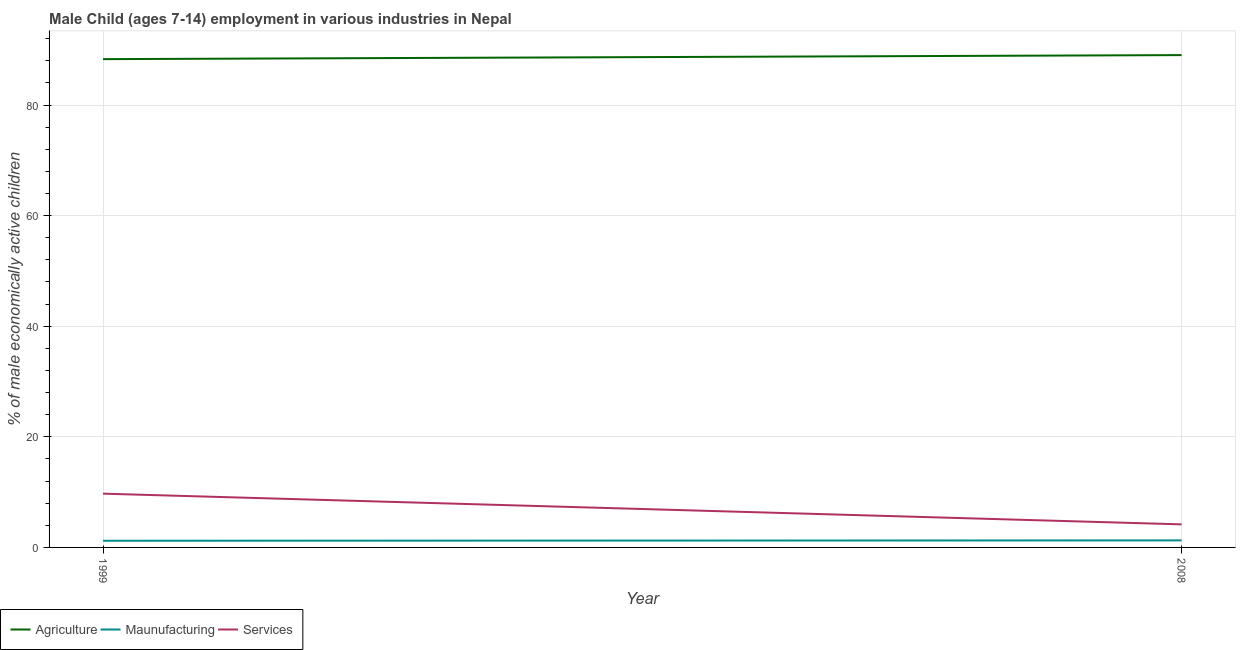Does the line corresponding to percentage of economically active children in manufacturing intersect with the line corresponding to percentage of economically active children in services?
Provide a short and direct response. No. Is the number of lines equal to the number of legend labels?
Your answer should be very brief. Yes. What is the percentage of economically active children in services in 1999?
Ensure brevity in your answer.  9.72. Across all years, what is the maximum percentage of economically active children in agriculture?
Your response must be concise. 89.03. Across all years, what is the minimum percentage of economically active children in manufacturing?
Provide a short and direct response. 1.2. In which year was the percentage of economically active children in services minimum?
Provide a short and direct response. 2008. What is the total percentage of economically active children in services in the graph?
Offer a very short reply. 13.89. What is the difference between the percentage of economically active children in agriculture in 1999 and that in 2008?
Your answer should be very brief. -0.73. What is the difference between the percentage of economically active children in services in 2008 and the percentage of economically active children in manufacturing in 1999?
Offer a terse response. 2.97. What is the average percentage of economically active children in agriculture per year?
Make the answer very short. 88.66. In the year 2008, what is the difference between the percentage of economically active children in services and percentage of economically active children in agriculture?
Offer a terse response. -84.86. In how many years, is the percentage of economically active children in services greater than 68 %?
Offer a terse response. 0. What is the ratio of the percentage of economically active children in manufacturing in 1999 to that in 2008?
Offer a terse response. 0.95. Is the percentage of economically active children in agriculture in 1999 less than that in 2008?
Keep it short and to the point. Yes. Is it the case that in every year, the sum of the percentage of economically active children in agriculture and percentage of economically active children in manufacturing is greater than the percentage of economically active children in services?
Your answer should be very brief. Yes. Is the percentage of economically active children in manufacturing strictly less than the percentage of economically active children in agriculture over the years?
Make the answer very short. Yes. How many lines are there?
Your answer should be compact. 3. How many years are there in the graph?
Your response must be concise. 2. Does the graph contain any zero values?
Your answer should be compact. No. Where does the legend appear in the graph?
Your answer should be very brief. Bottom left. How are the legend labels stacked?
Make the answer very short. Horizontal. What is the title of the graph?
Keep it short and to the point. Male Child (ages 7-14) employment in various industries in Nepal. Does "Agricultural raw materials" appear as one of the legend labels in the graph?
Your answer should be compact. No. What is the label or title of the Y-axis?
Your response must be concise. % of male economically active children. What is the % of male economically active children in Agriculture in 1999?
Your answer should be compact. 88.3. What is the % of male economically active children of Maunufacturing in 1999?
Ensure brevity in your answer.  1.2. What is the % of male economically active children of Services in 1999?
Offer a terse response. 9.72. What is the % of male economically active children in Agriculture in 2008?
Offer a terse response. 89.03. What is the % of male economically active children in Maunufacturing in 2008?
Offer a very short reply. 1.27. What is the % of male economically active children of Services in 2008?
Provide a succinct answer. 4.17. Across all years, what is the maximum % of male economically active children of Agriculture?
Your answer should be very brief. 89.03. Across all years, what is the maximum % of male economically active children of Maunufacturing?
Ensure brevity in your answer.  1.27. Across all years, what is the maximum % of male economically active children of Services?
Give a very brief answer. 9.72. Across all years, what is the minimum % of male economically active children in Agriculture?
Offer a very short reply. 88.3. Across all years, what is the minimum % of male economically active children in Maunufacturing?
Ensure brevity in your answer.  1.2. Across all years, what is the minimum % of male economically active children in Services?
Your response must be concise. 4.17. What is the total % of male economically active children of Agriculture in the graph?
Provide a short and direct response. 177.33. What is the total % of male economically active children in Maunufacturing in the graph?
Offer a very short reply. 2.47. What is the total % of male economically active children in Services in the graph?
Provide a short and direct response. 13.89. What is the difference between the % of male economically active children of Agriculture in 1999 and that in 2008?
Offer a terse response. -0.73. What is the difference between the % of male economically active children of Maunufacturing in 1999 and that in 2008?
Your answer should be compact. -0.07. What is the difference between the % of male economically active children of Services in 1999 and that in 2008?
Your answer should be very brief. 5.55. What is the difference between the % of male economically active children in Agriculture in 1999 and the % of male economically active children in Maunufacturing in 2008?
Provide a succinct answer. 87.03. What is the difference between the % of male economically active children in Agriculture in 1999 and the % of male economically active children in Services in 2008?
Your response must be concise. 84.13. What is the difference between the % of male economically active children of Maunufacturing in 1999 and the % of male economically active children of Services in 2008?
Provide a succinct answer. -2.97. What is the average % of male economically active children in Agriculture per year?
Offer a very short reply. 88.67. What is the average % of male economically active children of Maunufacturing per year?
Make the answer very short. 1.24. What is the average % of male economically active children of Services per year?
Offer a very short reply. 6.95. In the year 1999, what is the difference between the % of male economically active children of Agriculture and % of male economically active children of Maunufacturing?
Your response must be concise. 87.1. In the year 1999, what is the difference between the % of male economically active children in Agriculture and % of male economically active children in Services?
Offer a terse response. 78.58. In the year 1999, what is the difference between the % of male economically active children in Maunufacturing and % of male economically active children in Services?
Your answer should be compact. -8.52. In the year 2008, what is the difference between the % of male economically active children in Agriculture and % of male economically active children in Maunufacturing?
Give a very brief answer. 87.76. In the year 2008, what is the difference between the % of male economically active children in Agriculture and % of male economically active children in Services?
Ensure brevity in your answer.  84.86. What is the ratio of the % of male economically active children of Agriculture in 1999 to that in 2008?
Provide a short and direct response. 0.99. What is the ratio of the % of male economically active children of Maunufacturing in 1999 to that in 2008?
Offer a terse response. 0.95. What is the ratio of the % of male economically active children of Services in 1999 to that in 2008?
Make the answer very short. 2.33. What is the difference between the highest and the second highest % of male economically active children of Agriculture?
Make the answer very short. 0.73. What is the difference between the highest and the second highest % of male economically active children of Maunufacturing?
Offer a terse response. 0.07. What is the difference between the highest and the second highest % of male economically active children in Services?
Give a very brief answer. 5.55. What is the difference between the highest and the lowest % of male economically active children in Agriculture?
Offer a terse response. 0.73. What is the difference between the highest and the lowest % of male economically active children of Maunufacturing?
Offer a very short reply. 0.07. What is the difference between the highest and the lowest % of male economically active children in Services?
Provide a short and direct response. 5.55. 